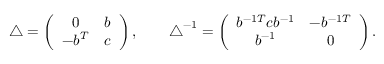Convert formula to latex. <formula><loc_0><loc_0><loc_500><loc_500>\begin{array} { r } { \triangle = \left ( \begin{array} { c c } { 0 } & { b } \\ { - b ^ { T } } & { c } \end{array} \right ) , \quad \triangle ^ { - 1 } = \left ( \begin{array} { c c } { b ^ { - 1 T } c b ^ { - 1 } } & { - b ^ { - 1 T } } \\ { b ^ { - 1 } } & { 0 } \end{array} \right ) . } \end{array}</formula> 